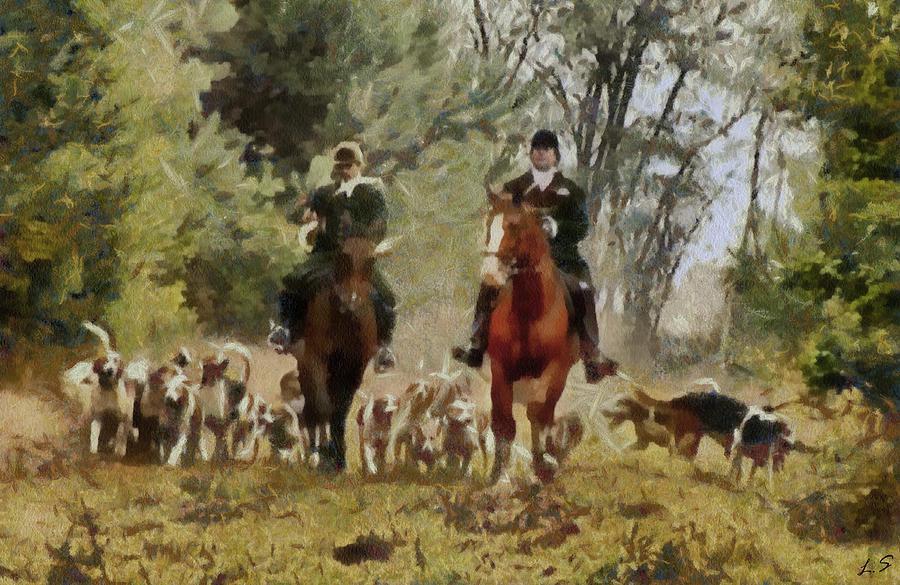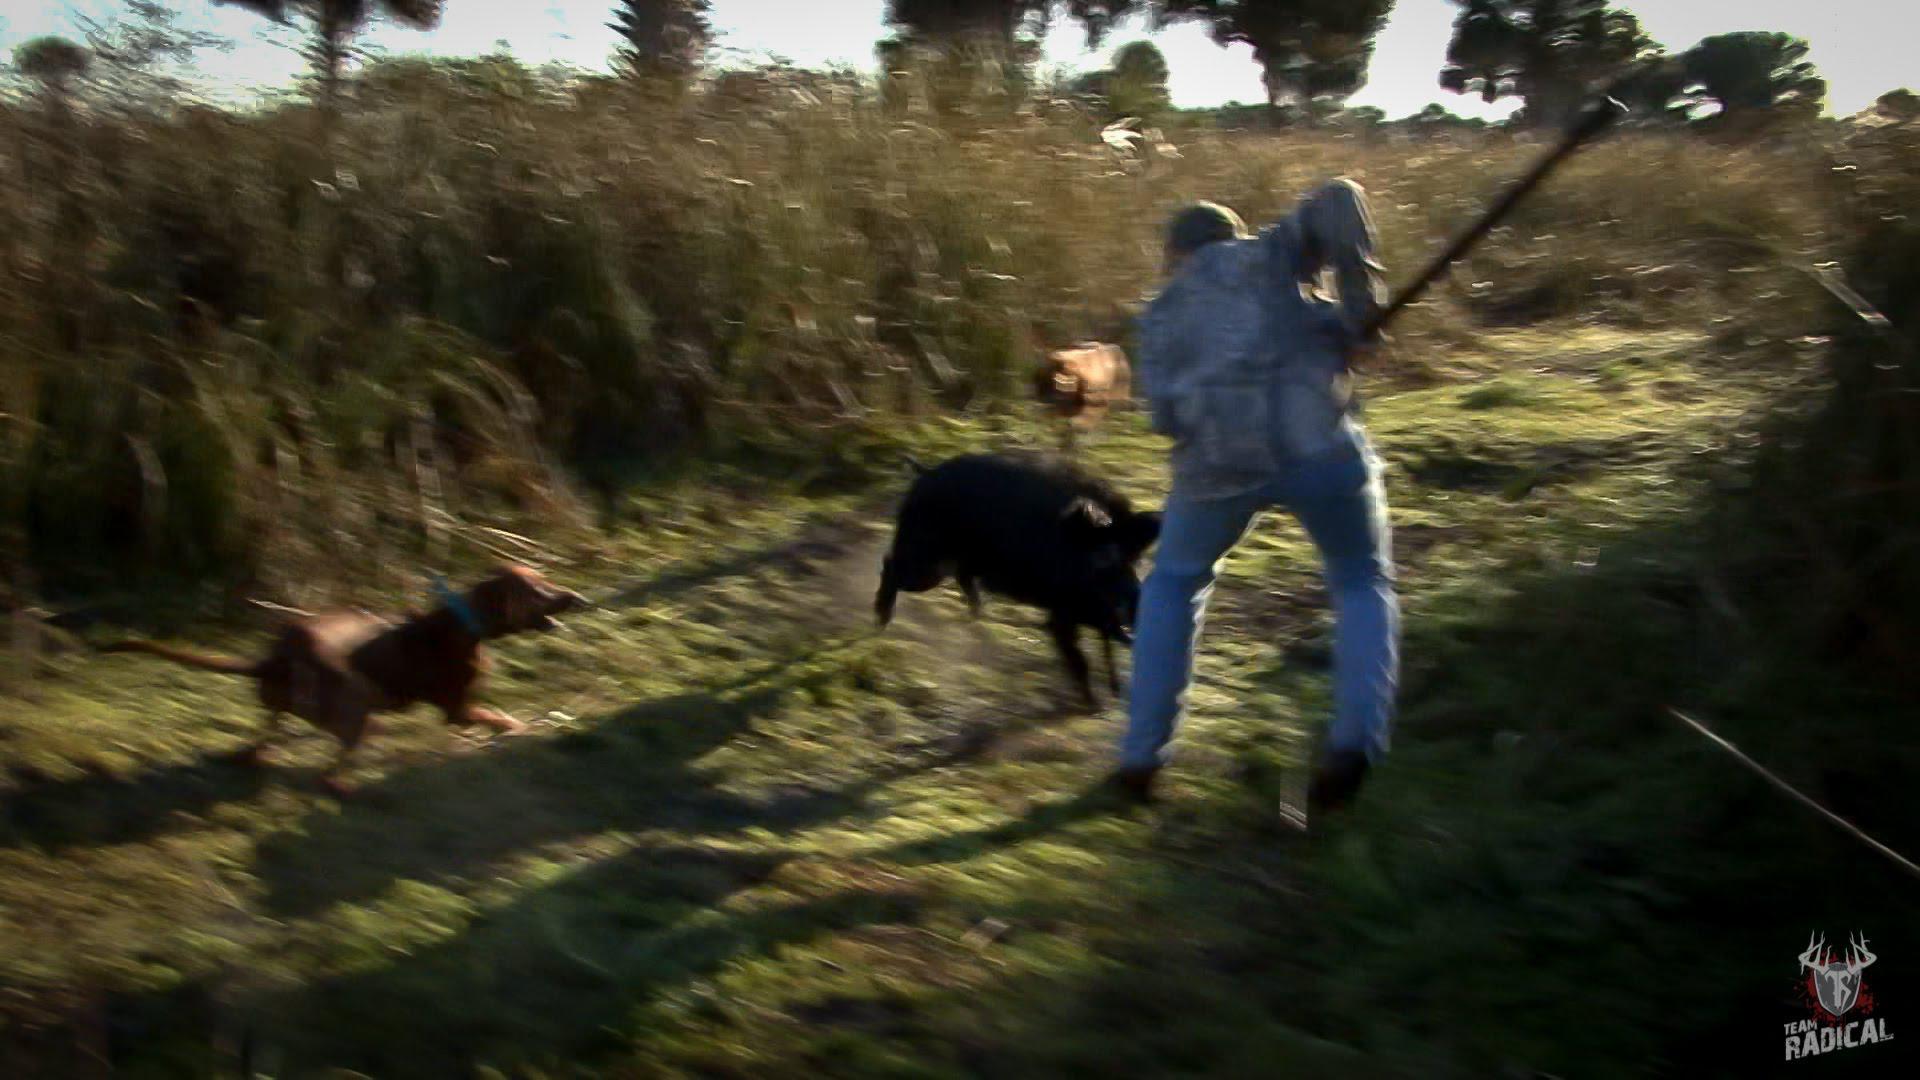The first image is the image on the left, the second image is the image on the right. Examine the images to the left and right. Is the description "there is a dead boar with it's mouth wide open and a man with a long blade spear sitting behind it" accurate? Answer yes or no. No. The first image is the image on the left, the second image is the image on the right. Analyze the images presented: Is the assertion "A male person grasping a spear in both hands is by a killed hog positioned on the ground with its open-mouthed face toward the camera." valid? Answer yes or no. No. 